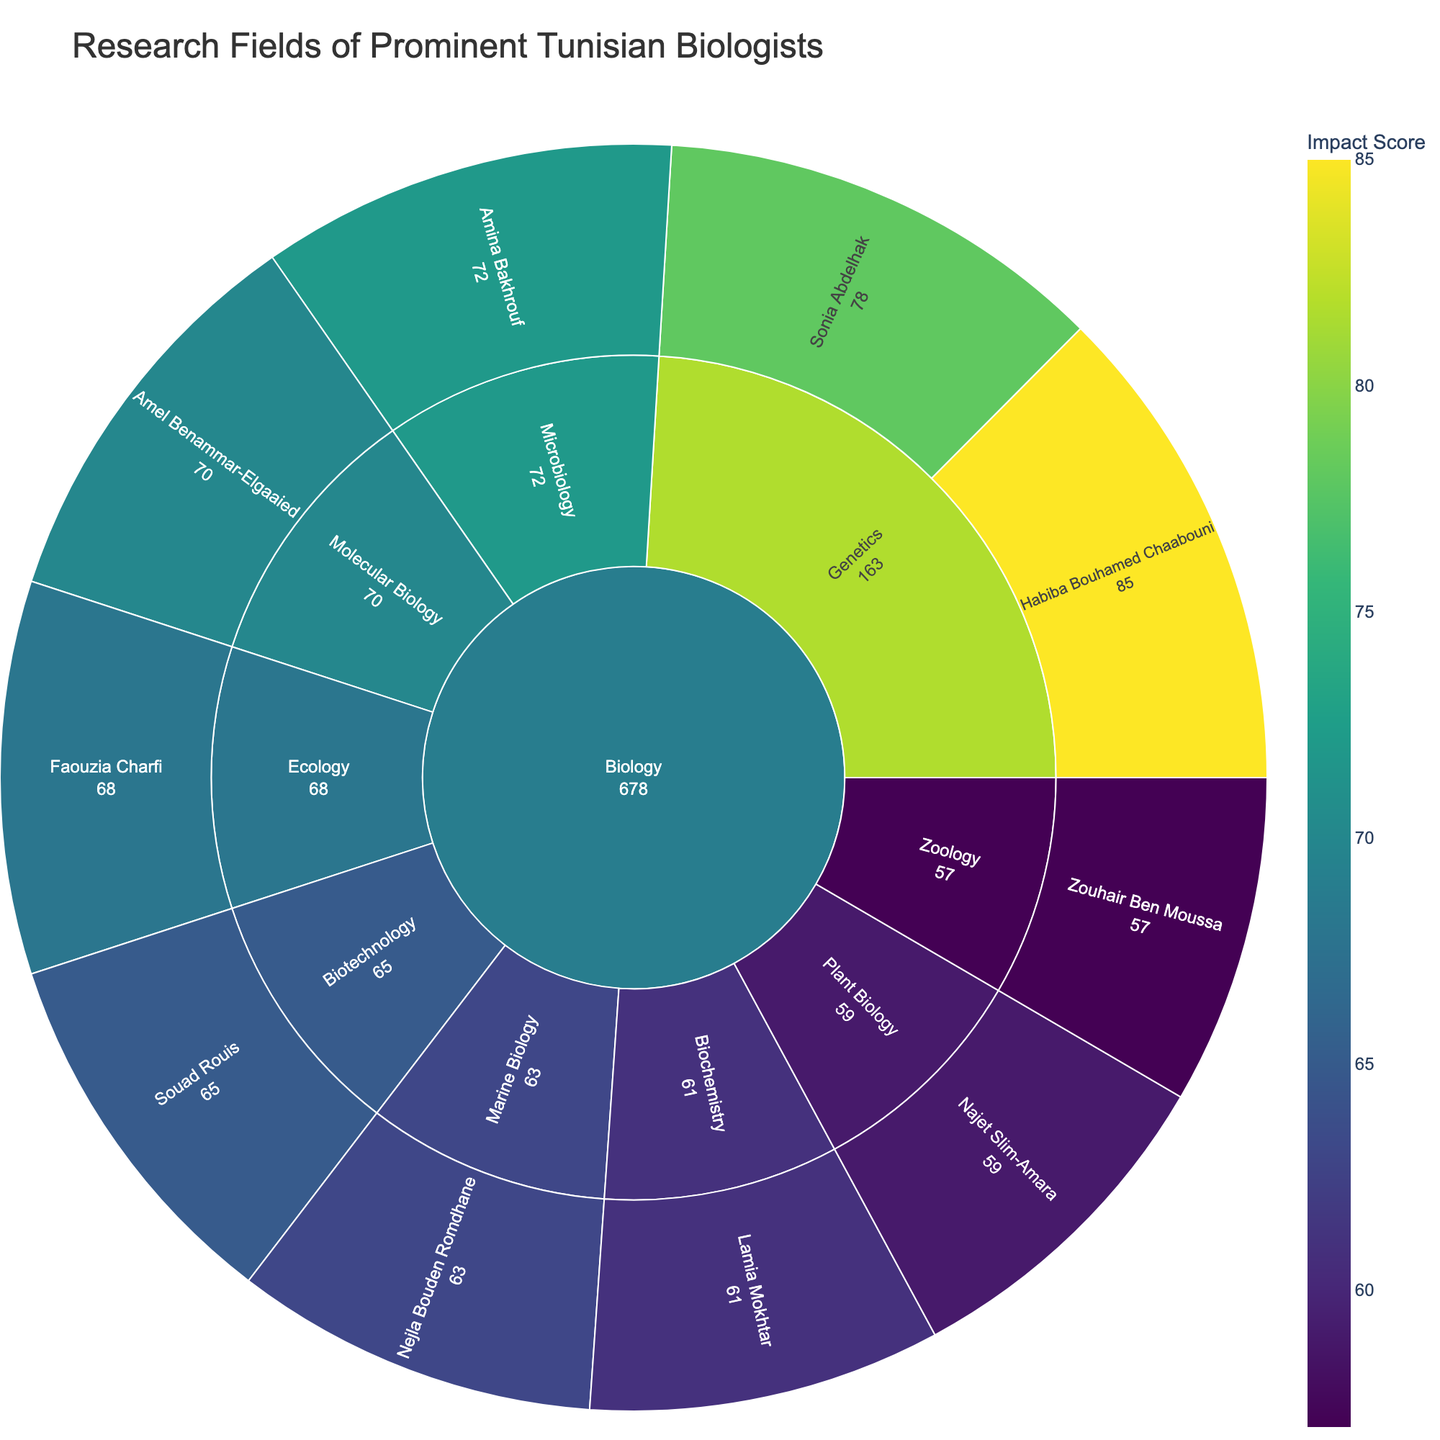Which specialization has the highest impact score? Looking at the color intensity and the numerical values, Genetics stands out with the highest impact scores of 85 and 78.
Answer: Genetics Who is the scientist with the lowest impact score and what is their specialization? By inspecting the lowest numeric value on the plot, Zouhair Ben Moussa has the lowest impact score of 57, specialized in Zoology.
Answer: Zouhair Ben Moussa, Zoology What is the total impact score for scientists specializing in Genetics? Summing the impact scores of Habiba Bouhamed Chaabouni (85) and Sonia Abdelhak (78) within the Genetics specialization: 85 + 78 = 163
Answer: 163 Compare the impact scores of scientists in Marine Biology and Plant Biology. Which specialization has a higher total impact score? Marine Biology has one scientist with an impact score of 63, while Plant Biology's scientist has an impact score of 59. 63 (Marine Biology) is higher than 59 (Plant Biology).
Answer: Marine Biology What is the average impact score of the biologists listed in the plot? Summing all the impact scores: 85 + 78 + 72 + 68 + 65 + 70 + 63 + 59 + 61 + 57 = 678. Dividing by the number of scientists (10): 678 / 10 = 67.8
Answer: 67.8 Which scientist has an impact score equal to or above 70 but below 80? By checking the impact scores, Amel Benammar-Elgaaied with a score of 70 and Sonia Abdelhak with a score of 78 fit this range.
Answer: Amel Benammar-Elgaaied, Sonia Abdelhak Identify the specialization with the lowest total impact score. By summing individual impact scores for each specialization, Zoology has the lowest total with only one scientist scoring 57.
Answer: Zoology From which research field do the most scientists belong? Observing the outermost ring of the sunburst plot, all scientists belong to the Biology field making it the one with the most scientists.
Answer: Biology 